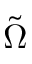Convert formula to latex. <formula><loc_0><loc_0><loc_500><loc_500>\tilde { \Omega }</formula> 